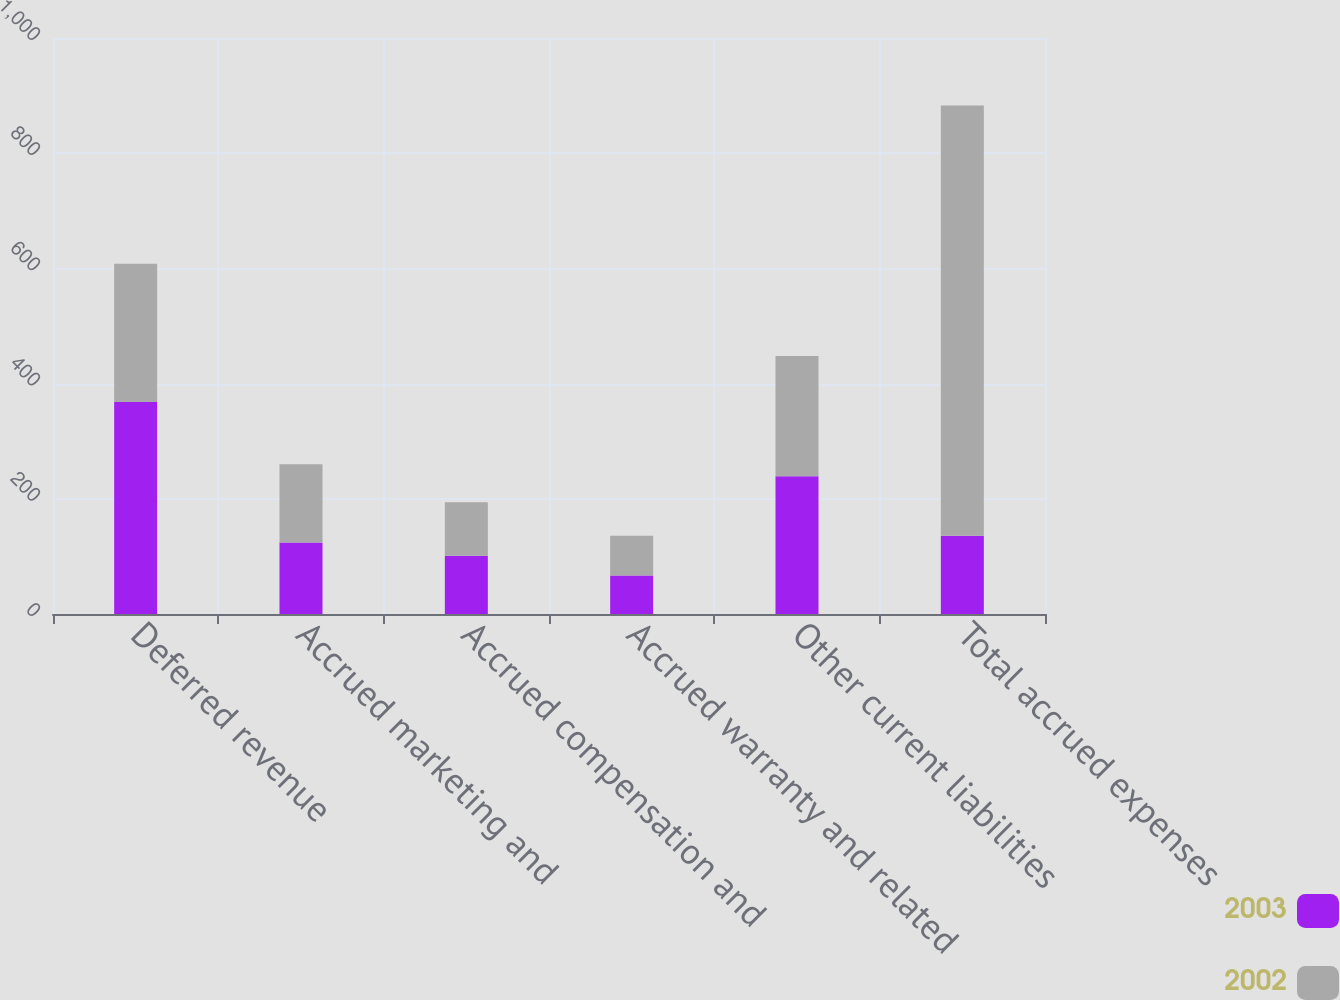<chart> <loc_0><loc_0><loc_500><loc_500><stacked_bar_chart><ecel><fcel>Deferred revenue<fcel>Accrued marketing and<fcel>Accrued compensation and<fcel>Accrued warranty and related<fcel>Other current liabilities<fcel>Total accrued expenses<nl><fcel>2003<fcel>368<fcel>124<fcel>101<fcel>67<fcel>239<fcel>136<nl><fcel>2002<fcel>240<fcel>136<fcel>93<fcel>69<fcel>209<fcel>747<nl></chart> 